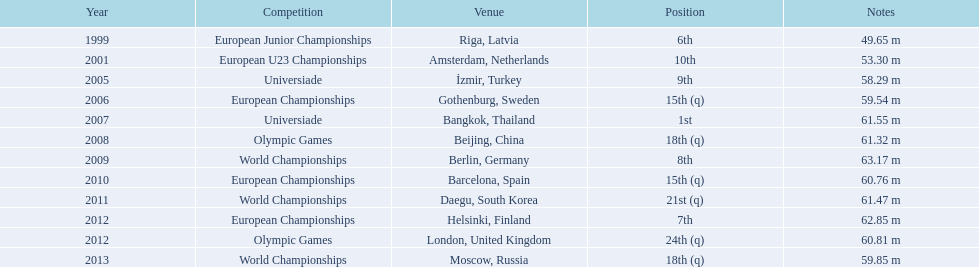What european underage championships? 6th. What was the european underage championships' best performance? 63.17 m. 